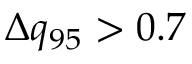<formula> <loc_0><loc_0><loc_500><loc_500>\Delta q _ { 9 5 } > 0 . 7</formula> 